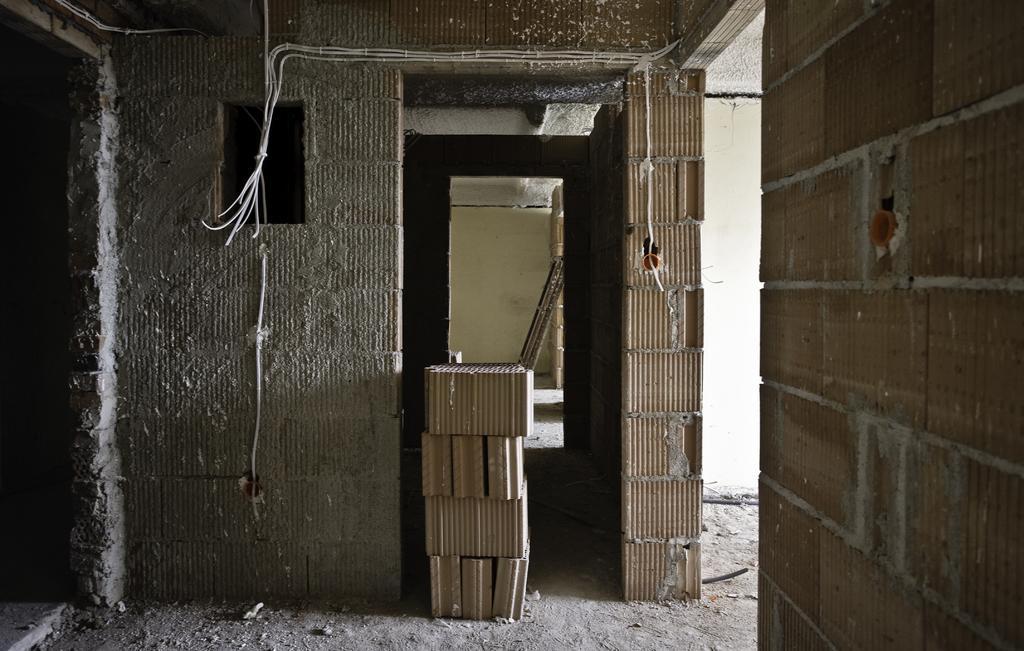Could you give a brief overview of what you see in this image? In this picture we can see tiles near to the wall. Here we can see gate. On the right there is a brick wall. 